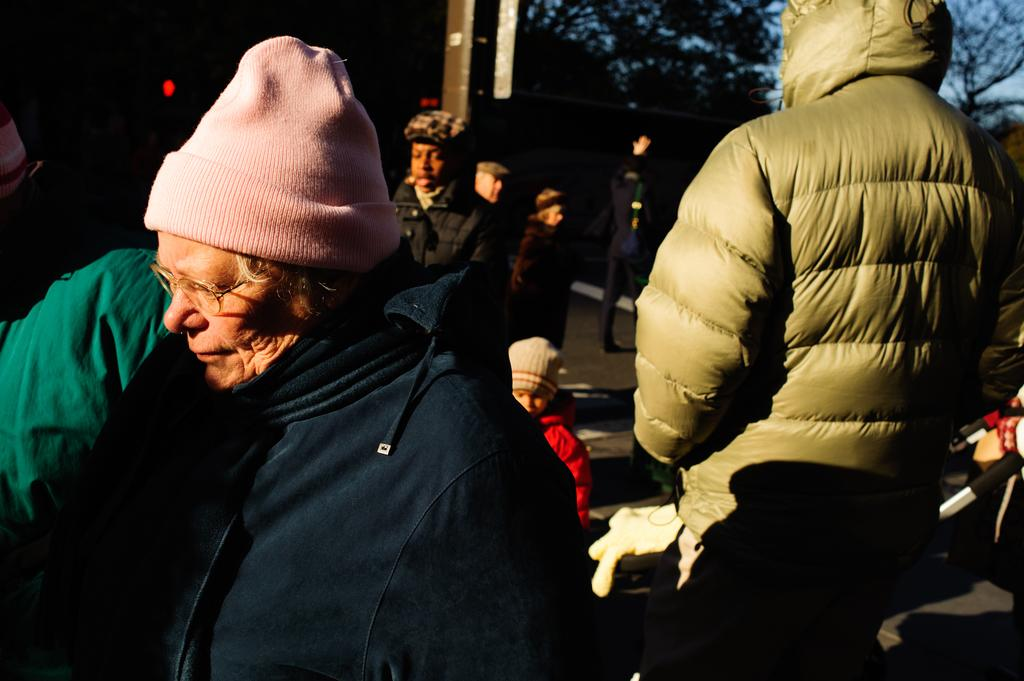What are the people in the image doing? The people in the image are standing on the ground. What type of clothing are the people wearing? The people are wearing jackets and head caps. What can be seen in the background of the image? There are trees in the background of the image. How is the background of the image depicted? The background of the image is blurred. What type of fireman equipment can be seen in the image? There is no fireman equipment present in the image. How many times does the ball roll across the ground in the image? There is no ball present in the image, so it cannot roll across the ground. 